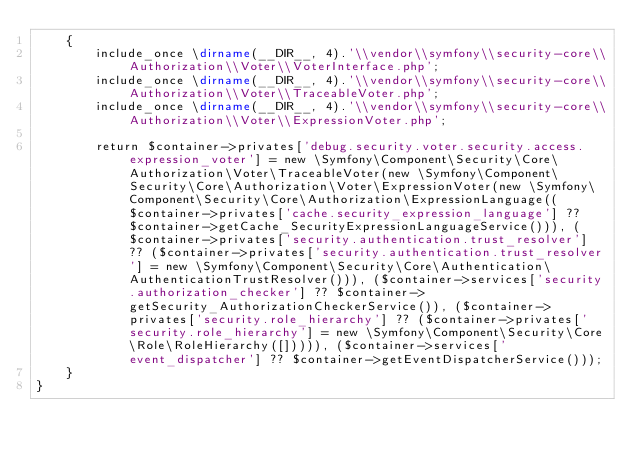<code> <loc_0><loc_0><loc_500><loc_500><_PHP_>    {
        include_once \dirname(__DIR__, 4).'\\vendor\\symfony\\security-core\\Authorization\\Voter\\VoterInterface.php';
        include_once \dirname(__DIR__, 4).'\\vendor\\symfony\\security-core\\Authorization\\Voter\\TraceableVoter.php';
        include_once \dirname(__DIR__, 4).'\\vendor\\symfony\\security-core\\Authorization\\Voter\\ExpressionVoter.php';

        return $container->privates['debug.security.voter.security.access.expression_voter'] = new \Symfony\Component\Security\Core\Authorization\Voter\TraceableVoter(new \Symfony\Component\Security\Core\Authorization\Voter\ExpressionVoter(new \Symfony\Component\Security\Core\Authorization\ExpressionLanguage(($container->privates['cache.security_expression_language'] ?? $container->getCache_SecurityExpressionLanguageService())), ($container->privates['security.authentication.trust_resolver'] ?? ($container->privates['security.authentication.trust_resolver'] = new \Symfony\Component\Security\Core\Authentication\AuthenticationTrustResolver())), ($container->services['security.authorization_checker'] ?? $container->getSecurity_AuthorizationCheckerService()), ($container->privates['security.role_hierarchy'] ?? ($container->privates['security.role_hierarchy'] = new \Symfony\Component\Security\Core\Role\RoleHierarchy([])))), ($container->services['event_dispatcher'] ?? $container->getEventDispatcherService()));
    }
}
</code> 